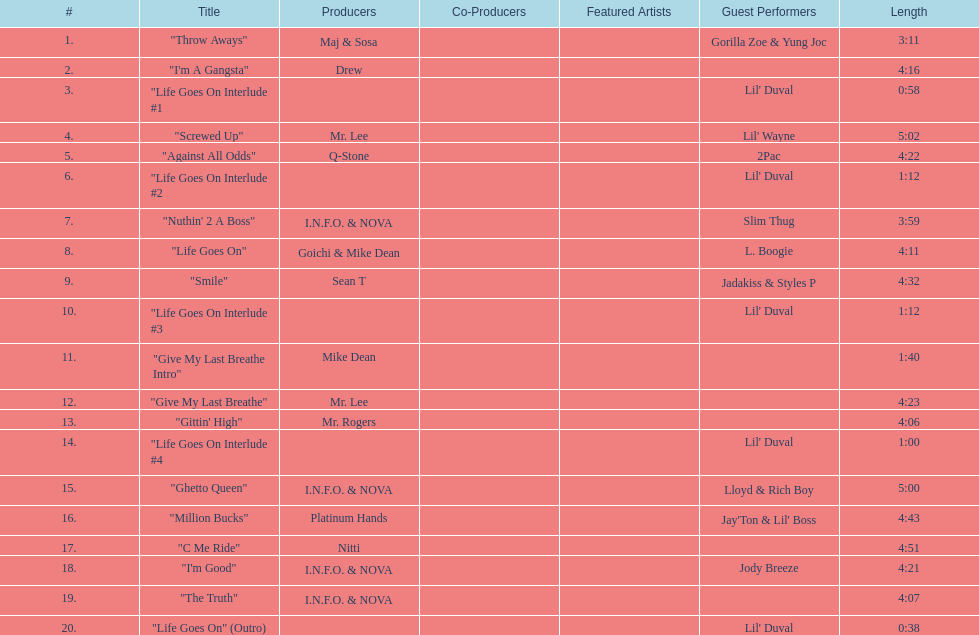How long is track number 11? 1:40. 